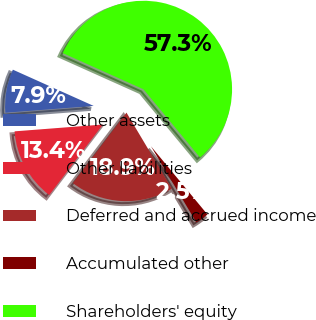Convert chart to OTSL. <chart><loc_0><loc_0><loc_500><loc_500><pie_chart><fcel>Other assets<fcel>Other liabilities<fcel>Deferred and accrued income<fcel>Accumulated other<fcel>Shareholders' equity<nl><fcel>7.94%<fcel>13.42%<fcel>18.9%<fcel>2.46%<fcel>57.27%<nl></chart> 